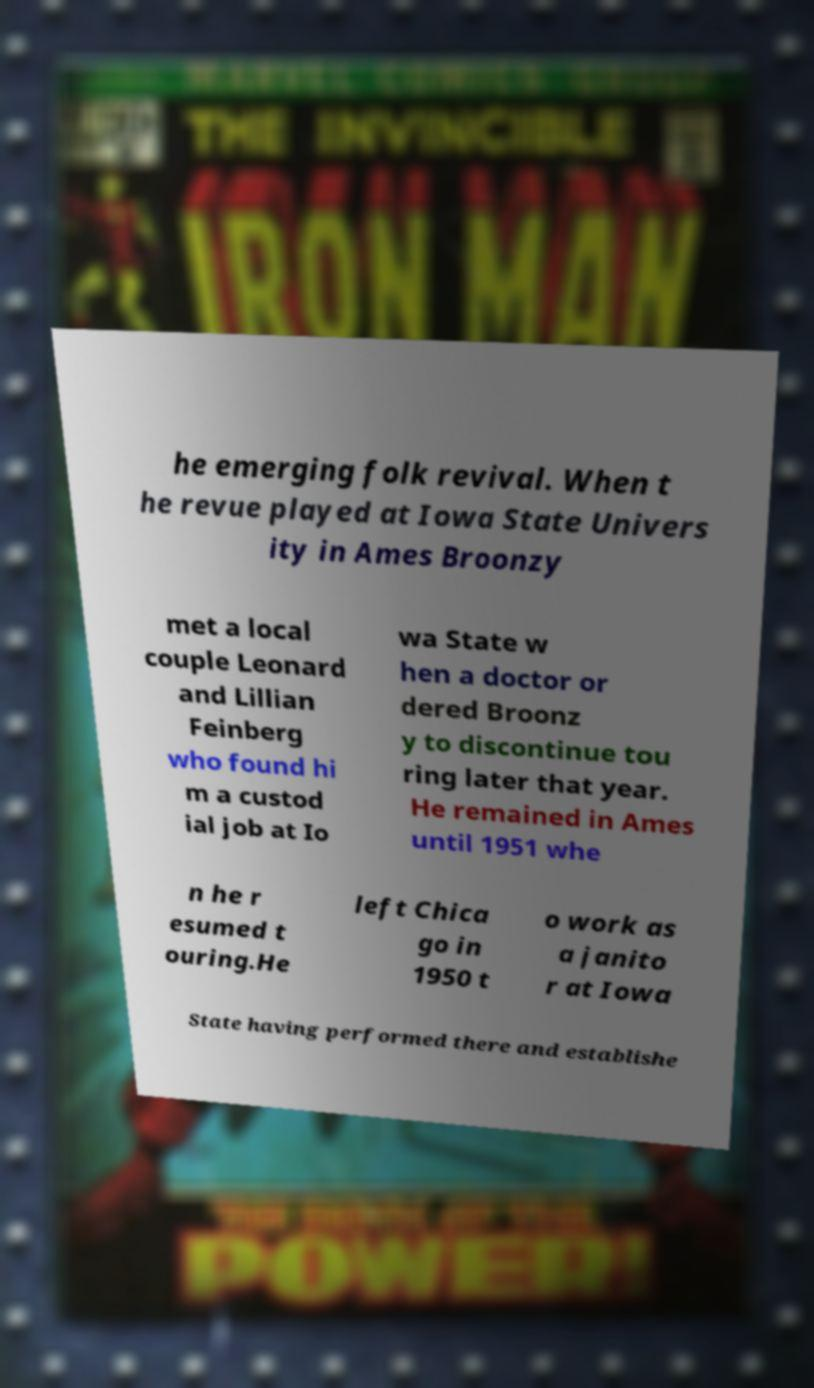I need the written content from this picture converted into text. Can you do that? he emerging folk revival. When t he revue played at Iowa State Univers ity in Ames Broonzy met a local couple Leonard and Lillian Feinberg who found hi m a custod ial job at Io wa State w hen a doctor or dered Broonz y to discontinue tou ring later that year. He remained in Ames until 1951 whe n he r esumed t ouring.He left Chica go in 1950 t o work as a janito r at Iowa State having performed there and establishe 